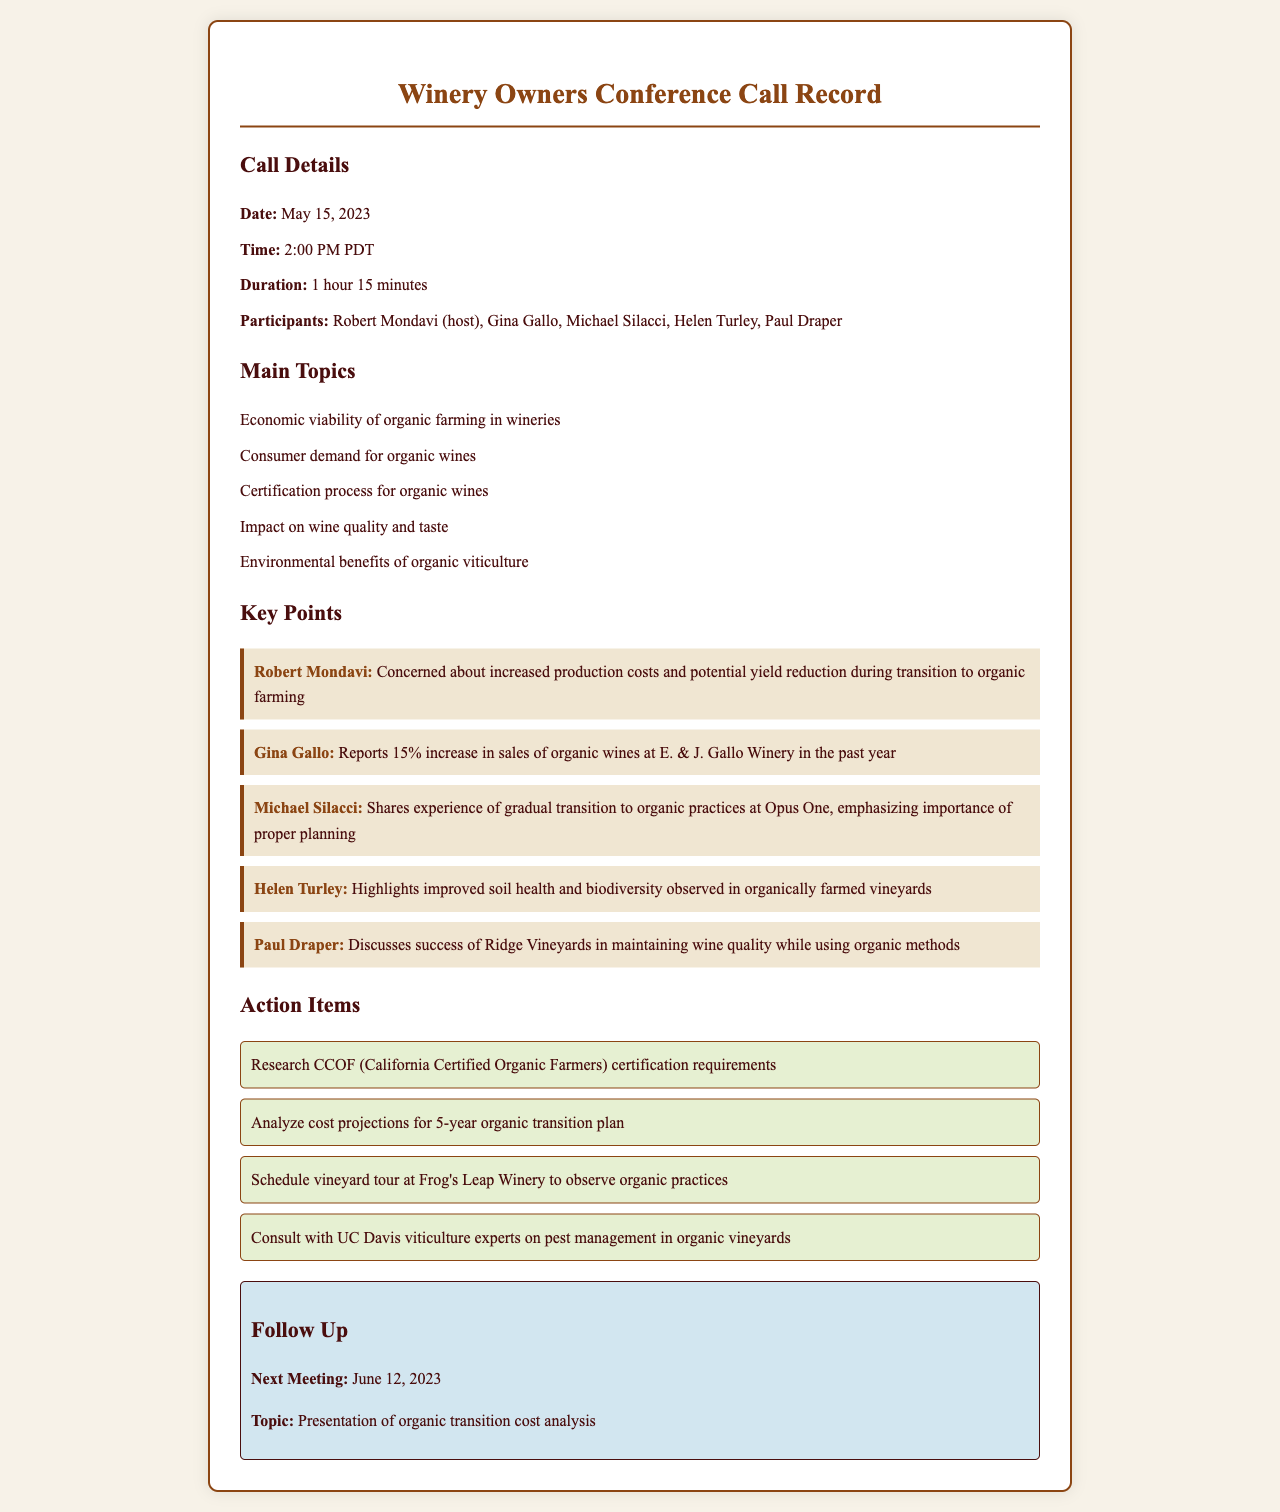What is the date of the conference call? The date of the conference call is explicitly stated in the document.
Answer: May 15, 2023 Who hosted the conference call? The host of the conference call is mentioned at the beginning of the document.
Answer: Robert Mondavi Which winery reported a 15% increase in sales of organic wines? This information can be found in the key points section of the document.
Answer: E. & J. Gallo Winery What is one of the action items discussed in the call? The action items are listed in a specific section of the document.
Answer: Research CCOF certification requirements What topic will be discussed in the next meeting? The topic for the next meeting is explicitly mentioned in the follow-up section.
Answer: Presentation of organic transition cost analysis What concern did Robert Mondavi express during the call? Robert Mondavi's concerns are outlined in one of the key points.
Answer: Increased production costs and potential yield reduction during transition to organic farming What is one environmental benefit highlighted by Helen Turley? Helen Turley mentioned specific benefits in her key point.
Answer: Improved soil health and biodiversity 